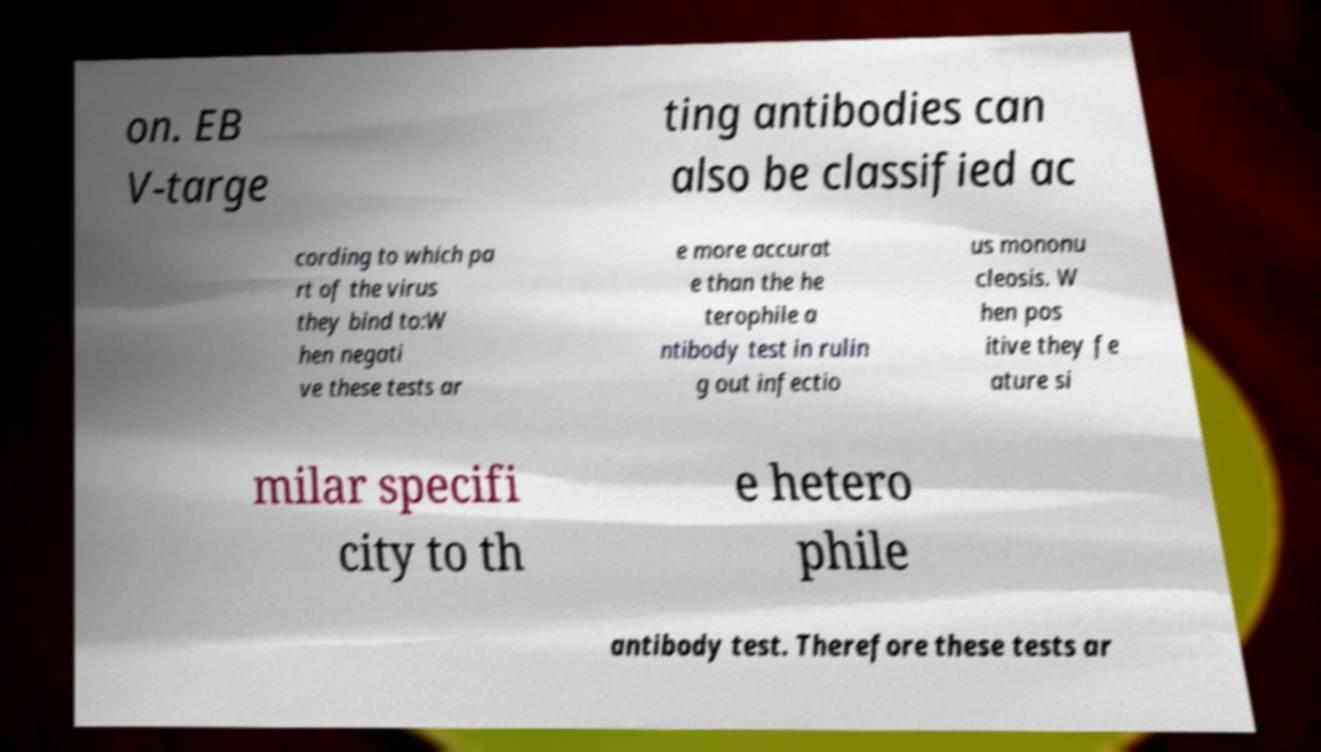Please identify and transcribe the text found in this image. on. EB V-targe ting antibodies can also be classified ac cording to which pa rt of the virus they bind to:W hen negati ve these tests ar e more accurat e than the he terophile a ntibody test in rulin g out infectio us mononu cleosis. W hen pos itive they fe ature si milar specifi city to th e hetero phile antibody test. Therefore these tests ar 